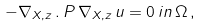Convert formula to latex. <formula><loc_0><loc_0><loc_500><loc_500>- \nabla _ { X , z } \, . \, P \, \nabla _ { X , z } \, u = 0 \, i n \, \Omega \, ,</formula> 